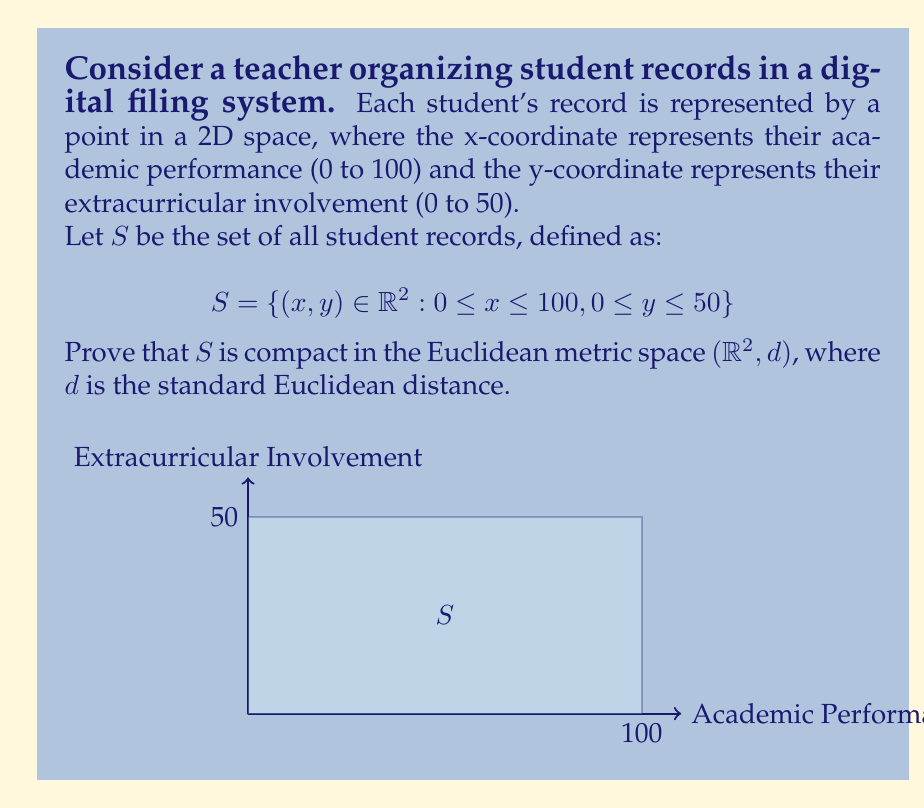Solve this math problem. To prove that $S$ is compact in $(\mathbb{R}^2, d)$, we'll show that it's closed and bounded, which is equivalent to compactness in Euclidean spaces (by the Heine-Borel theorem).

1. Closed:
   $S$ can be written as the intersection of four closed half-spaces:
   $$S = \{(x,y) : x \geq 0\} \cap \{(x,y) : x \leq 100\} \cap \{(x,y) : y \geq 0\} \cap \{(x,y) : y \leq 50\}$$
   Each half-space is closed, and the intersection of closed sets is closed. Therefore, $S$ is closed.

2. Bounded:
   Let $(x,y)$ be any point in $S$. Then:
   $$0 \leq x \leq 100 \text{ and } 0 \leq y \leq 50$$
   The distance from $(x,y)$ to the origin is:
   $$d((x,y), (0,0)) = \sqrt{x^2 + y^2} \leq \sqrt{100^2 + 50^2} = \sqrt{12500} \approx 111.8$$
   This shows that all points in $S$ are contained within a circle of radius $\sqrt{12500}$ centered at the origin. Therefore, $S$ is bounded.

Since $S$ is both closed and bounded in $(\mathbb{R}^2, d)$, it is compact by the Heine-Borel theorem.
Answer: $S$ is compact as it is closed (intersection of closed half-spaces) and bounded (contained in a circle of radius $\sqrt{12500}$). 